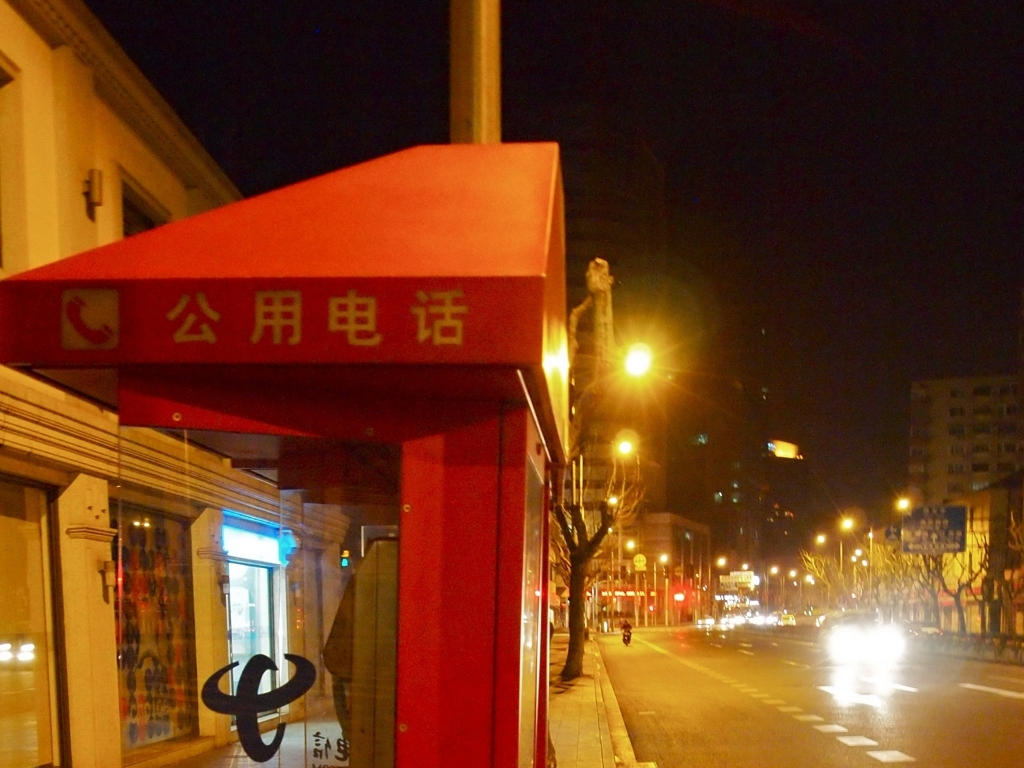What kind of establishment is under the awning, and how can you tell? Under the awning is a telephone booth, as indicated by the universal telephone symbol and its characteristic structure. Additionally, the text above the booth likely provides information regarding its function, although the image does not allow for a detailed reading of the characters. 